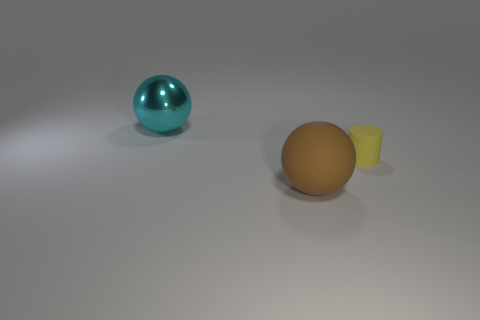What is the size of the sphere behind the large thing in front of the small object?
Your response must be concise. Large. The tiny matte object is what shape?
Offer a very short reply. Cylinder. What number of tiny things are either cyan shiny spheres or matte balls?
Your answer should be very brief. 0. What size is the cyan thing that is the same shape as the brown rubber thing?
Keep it short and to the point. Large. How many large spheres are behind the yellow rubber cylinder and in front of the matte cylinder?
Your response must be concise. 0. There is a cyan thing; is its shape the same as the large thing that is in front of the big cyan shiny object?
Your answer should be very brief. Yes. Is the number of tiny yellow rubber things that are right of the matte ball greater than the number of small blue objects?
Your answer should be compact. Yes. Are there fewer cyan things that are to the right of the tiny cylinder than yellow rubber cylinders?
Give a very brief answer. Yes. What number of metallic balls have the same color as the tiny matte object?
Provide a short and direct response. 0. The object that is both behind the rubber ball and left of the cylinder is made of what material?
Your answer should be compact. Metal. 